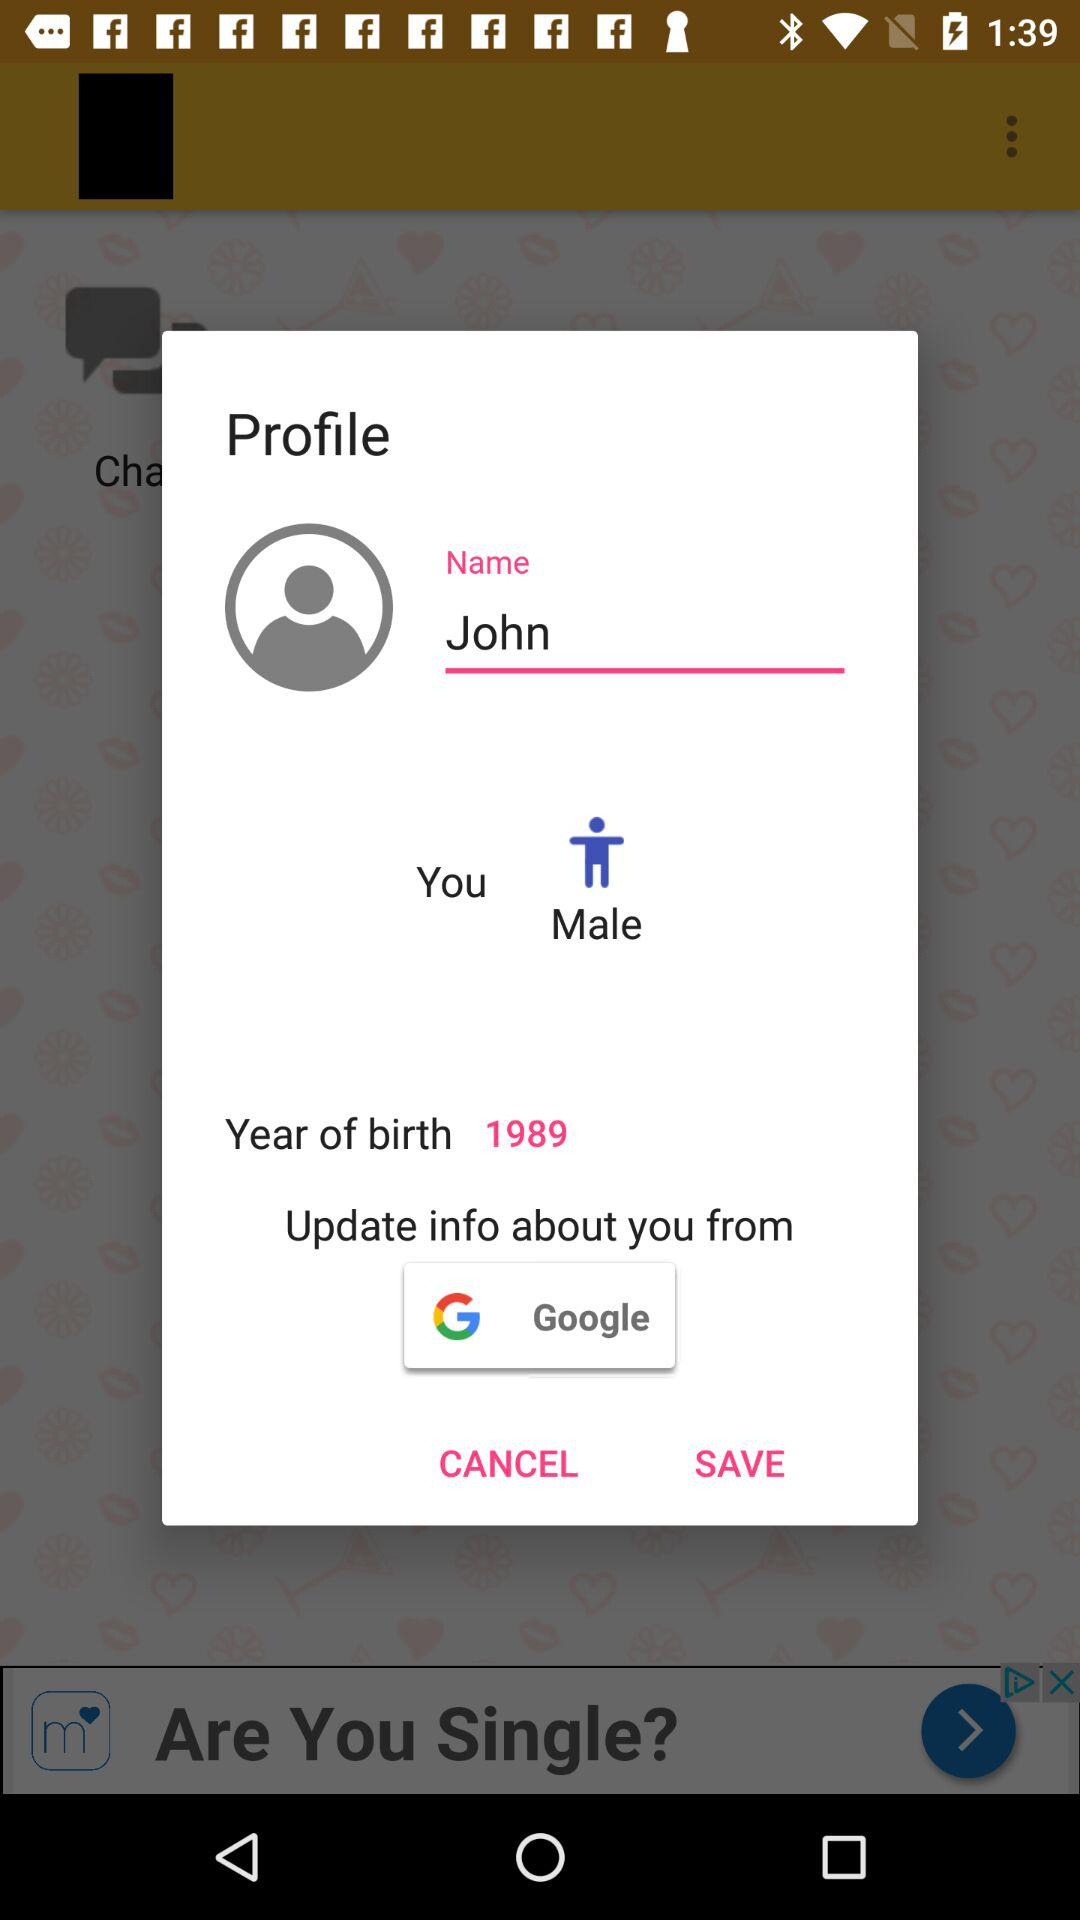What is the name of the user? The name of the user is John. 